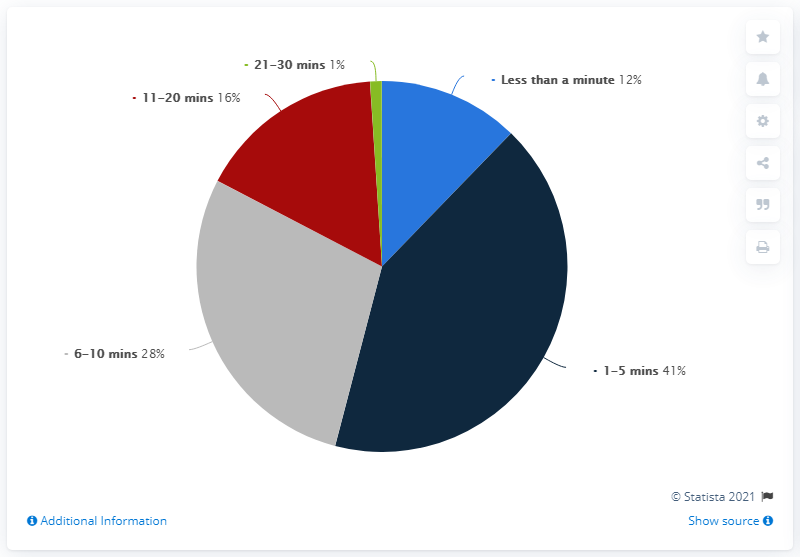Indicate a few pertinent items in this graphic. According to the data, 41% of people waited for 1-5 minutes at the airport. The percentage difference between the minimum and maximum time that people waited at the airport was 40%. 